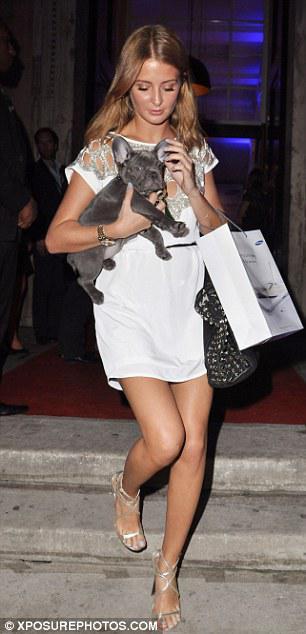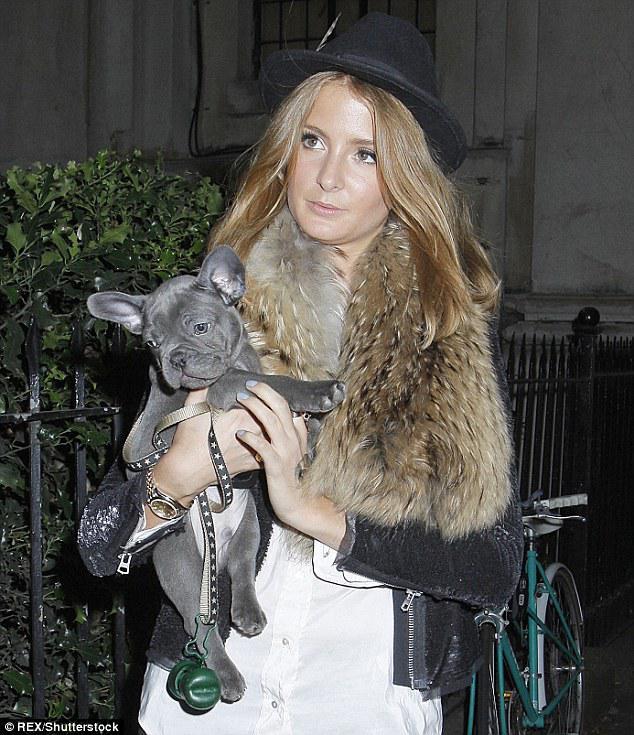The first image is the image on the left, the second image is the image on the right. Given the left and right images, does the statement "Both images in the pair show exactly one woman carrying a dog in her arms." hold true? Answer yes or no. Yes. The first image is the image on the left, the second image is the image on the right. For the images displayed, is the sentence "Each image shows just one woman standing with an arm around a dark gray bulldog, and the same woman is shown in both images." factually correct? Answer yes or no. Yes. 